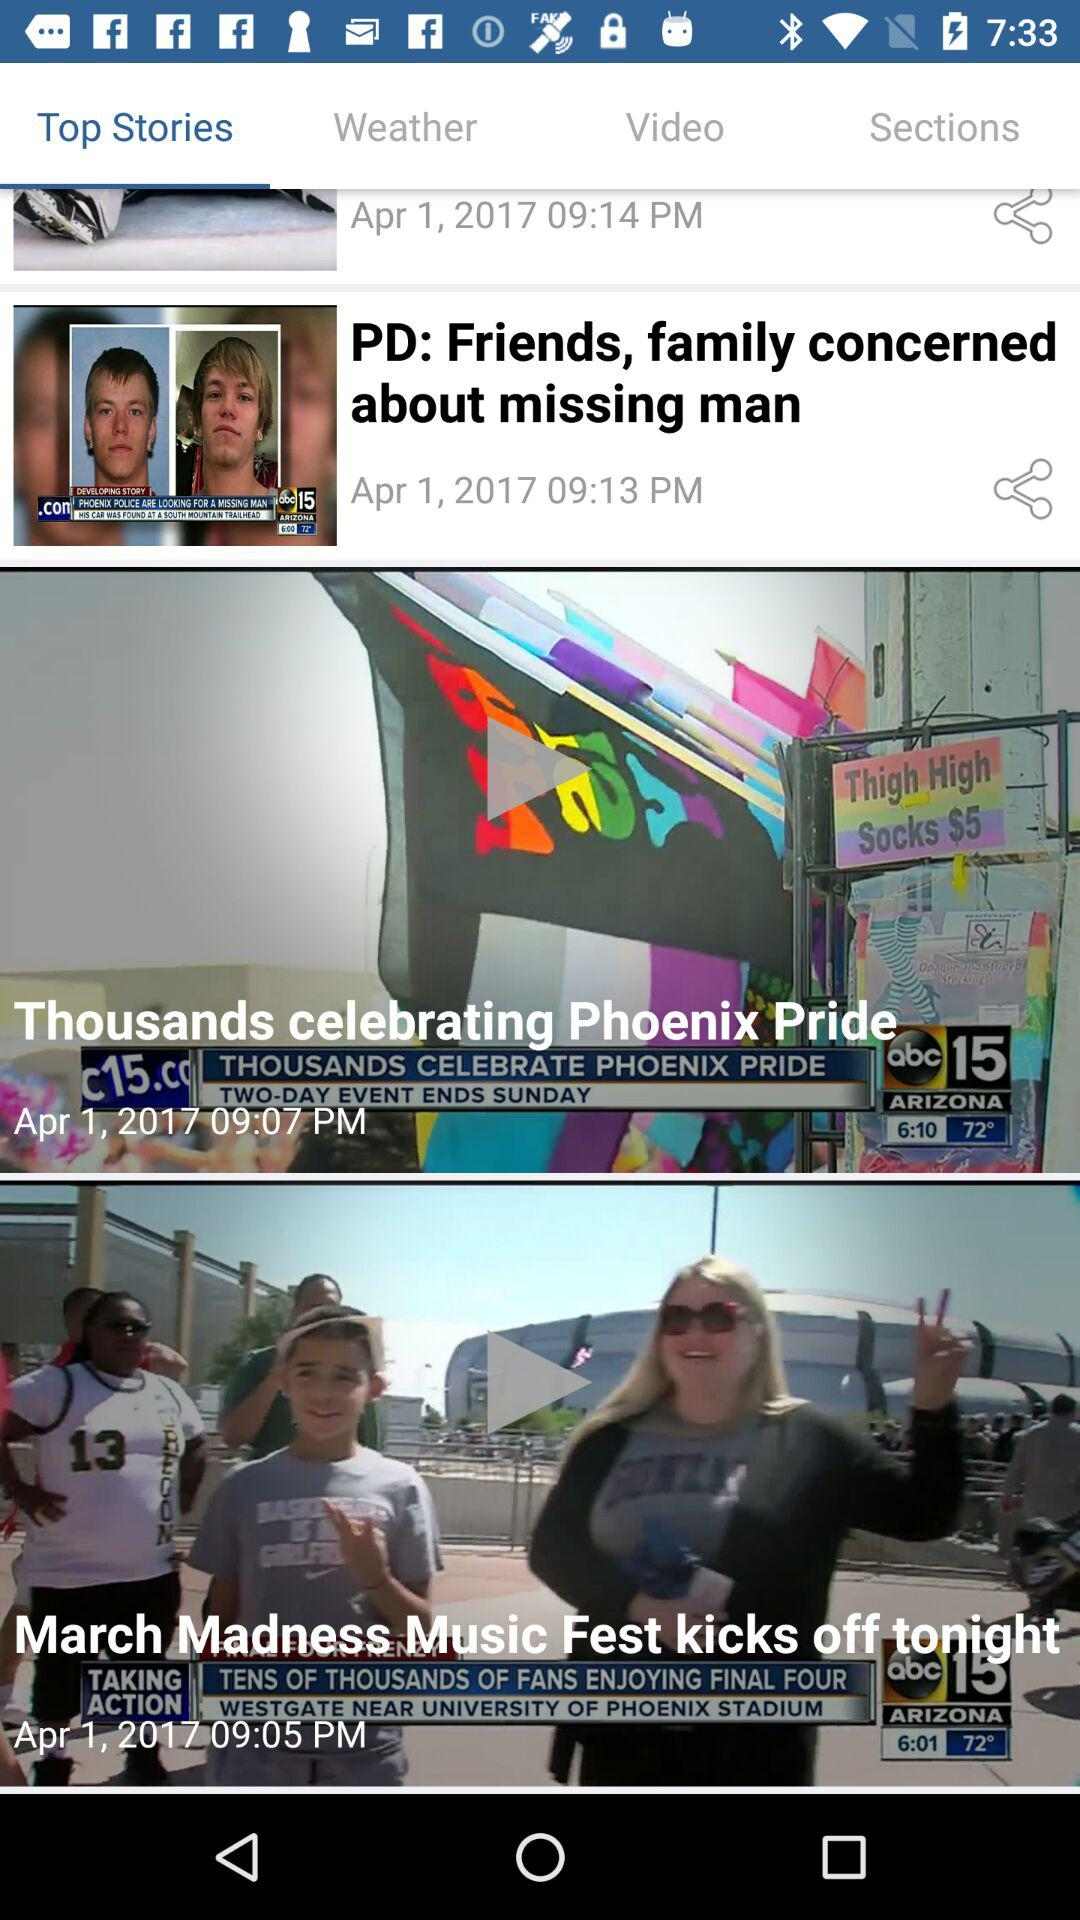What date was "Thousands celebrating Phoenix Pride" posted? It was posted on April 1, 2017. 